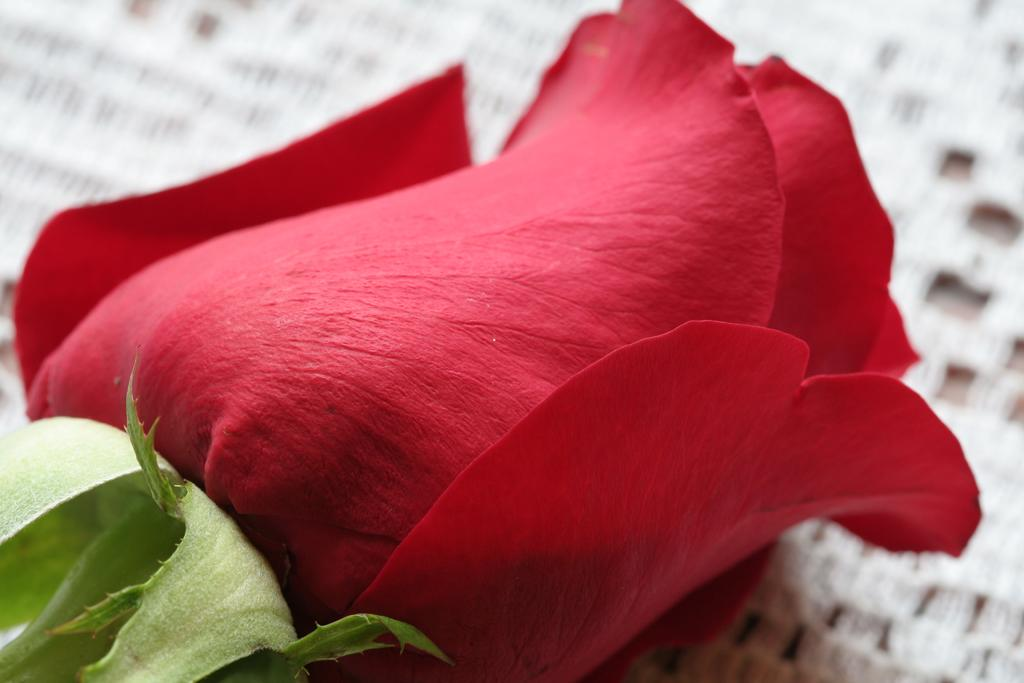What type of flower is in the image? There is a rose flower in the image. Can you see the ocean in the background of the image? There is no ocean present in the image; it only features a rose flower. 